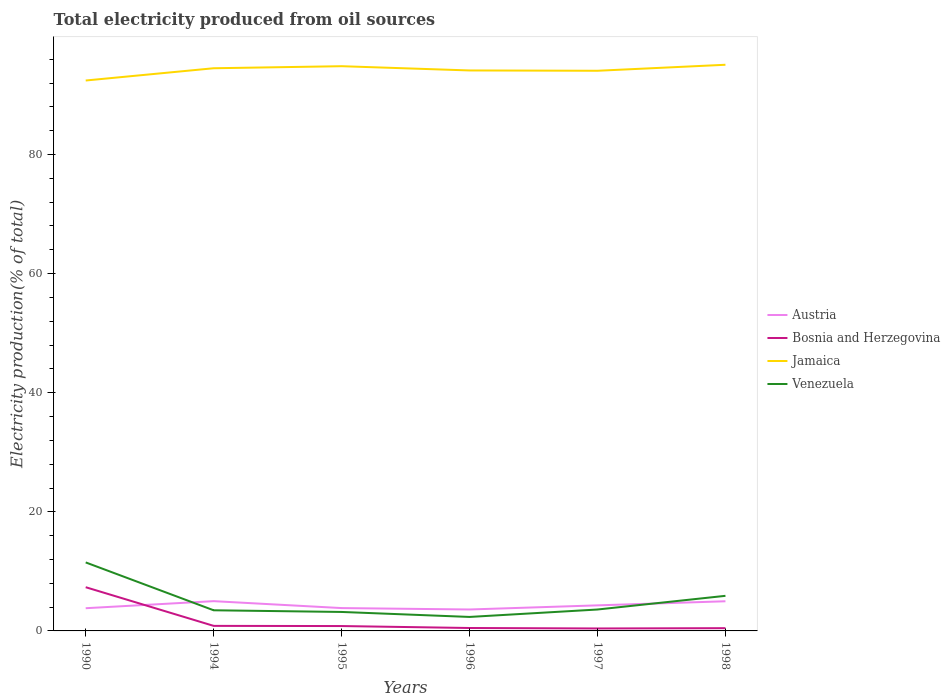How many different coloured lines are there?
Offer a terse response. 4. Does the line corresponding to Bosnia and Herzegovina intersect with the line corresponding to Austria?
Provide a short and direct response. Yes. Is the number of lines equal to the number of legend labels?
Make the answer very short. Yes. Across all years, what is the maximum total electricity produced in Venezuela?
Your answer should be very brief. 2.35. In which year was the total electricity produced in Jamaica maximum?
Provide a succinct answer. 1990. What is the total total electricity produced in Austria in the graph?
Give a very brief answer. -0.69. What is the difference between the highest and the second highest total electricity produced in Austria?
Keep it short and to the point. 1.4. What is the difference between the highest and the lowest total electricity produced in Jamaica?
Offer a terse response. 3. How many years are there in the graph?
Ensure brevity in your answer.  6. Where does the legend appear in the graph?
Your response must be concise. Center right. How many legend labels are there?
Make the answer very short. 4. What is the title of the graph?
Keep it short and to the point. Total electricity produced from oil sources. What is the Electricity production(% of total) in Austria in 1990?
Offer a very short reply. 3.81. What is the Electricity production(% of total) in Bosnia and Herzegovina in 1990?
Your answer should be compact. 7.34. What is the Electricity production(% of total) of Jamaica in 1990?
Provide a succinct answer. 92.43. What is the Electricity production(% of total) in Venezuela in 1990?
Your answer should be compact. 11.5. What is the Electricity production(% of total) in Austria in 1994?
Provide a succinct answer. 5. What is the Electricity production(% of total) of Bosnia and Herzegovina in 1994?
Keep it short and to the point. 0.85. What is the Electricity production(% of total) in Jamaica in 1994?
Give a very brief answer. 94.49. What is the Electricity production(% of total) of Venezuela in 1994?
Your response must be concise. 3.47. What is the Electricity production(% of total) in Austria in 1995?
Make the answer very short. 3.84. What is the Electricity production(% of total) of Bosnia and Herzegovina in 1995?
Provide a short and direct response. 0.82. What is the Electricity production(% of total) in Jamaica in 1995?
Give a very brief answer. 94.84. What is the Electricity production(% of total) of Venezuela in 1995?
Give a very brief answer. 3.18. What is the Electricity production(% of total) in Austria in 1996?
Make the answer very short. 3.6. What is the Electricity production(% of total) in Bosnia and Herzegovina in 1996?
Your answer should be very brief. 0.49. What is the Electricity production(% of total) in Jamaica in 1996?
Offer a terse response. 94.12. What is the Electricity production(% of total) of Venezuela in 1996?
Your answer should be compact. 2.35. What is the Electricity production(% of total) in Austria in 1997?
Give a very brief answer. 4.29. What is the Electricity production(% of total) in Bosnia and Herzegovina in 1997?
Keep it short and to the point. 0.41. What is the Electricity production(% of total) in Jamaica in 1997?
Provide a succinct answer. 94.07. What is the Electricity production(% of total) in Venezuela in 1997?
Keep it short and to the point. 3.6. What is the Electricity production(% of total) of Austria in 1998?
Offer a terse response. 4.98. What is the Electricity production(% of total) in Bosnia and Herzegovina in 1998?
Keep it short and to the point. 0.46. What is the Electricity production(% of total) of Jamaica in 1998?
Your response must be concise. 95.08. What is the Electricity production(% of total) of Venezuela in 1998?
Provide a succinct answer. 5.89. Across all years, what is the maximum Electricity production(% of total) in Austria?
Ensure brevity in your answer.  5. Across all years, what is the maximum Electricity production(% of total) of Bosnia and Herzegovina?
Keep it short and to the point. 7.34. Across all years, what is the maximum Electricity production(% of total) of Jamaica?
Your answer should be very brief. 95.08. Across all years, what is the maximum Electricity production(% of total) of Venezuela?
Your answer should be compact. 11.5. Across all years, what is the minimum Electricity production(% of total) of Austria?
Give a very brief answer. 3.6. Across all years, what is the minimum Electricity production(% of total) in Bosnia and Herzegovina?
Your response must be concise. 0.41. Across all years, what is the minimum Electricity production(% of total) of Jamaica?
Keep it short and to the point. 92.43. Across all years, what is the minimum Electricity production(% of total) in Venezuela?
Give a very brief answer. 2.35. What is the total Electricity production(% of total) of Austria in the graph?
Keep it short and to the point. 25.52. What is the total Electricity production(% of total) of Bosnia and Herzegovina in the graph?
Offer a very short reply. 10.37. What is the total Electricity production(% of total) in Jamaica in the graph?
Your response must be concise. 565.03. What is the total Electricity production(% of total) of Venezuela in the graph?
Provide a short and direct response. 29.99. What is the difference between the Electricity production(% of total) of Austria in 1990 and that in 1994?
Offer a very short reply. -1.19. What is the difference between the Electricity production(% of total) of Bosnia and Herzegovina in 1990 and that in 1994?
Your answer should be compact. 6.49. What is the difference between the Electricity production(% of total) of Jamaica in 1990 and that in 1994?
Keep it short and to the point. -2.06. What is the difference between the Electricity production(% of total) in Venezuela in 1990 and that in 1994?
Provide a short and direct response. 8.04. What is the difference between the Electricity production(% of total) in Austria in 1990 and that in 1995?
Keep it short and to the point. -0.02. What is the difference between the Electricity production(% of total) of Bosnia and Herzegovina in 1990 and that in 1995?
Provide a short and direct response. 6.52. What is the difference between the Electricity production(% of total) in Jamaica in 1990 and that in 1995?
Your answer should be very brief. -2.4. What is the difference between the Electricity production(% of total) in Venezuela in 1990 and that in 1995?
Provide a short and direct response. 8.32. What is the difference between the Electricity production(% of total) in Austria in 1990 and that in 1996?
Give a very brief answer. 0.21. What is the difference between the Electricity production(% of total) in Bosnia and Herzegovina in 1990 and that in 1996?
Give a very brief answer. 6.85. What is the difference between the Electricity production(% of total) of Jamaica in 1990 and that in 1996?
Keep it short and to the point. -1.69. What is the difference between the Electricity production(% of total) in Venezuela in 1990 and that in 1996?
Give a very brief answer. 9.16. What is the difference between the Electricity production(% of total) of Austria in 1990 and that in 1997?
Your response must be concise. -0.48. What is the difference between the Electricity production(% of total) of Bosnia and Herzegovina in 1990 and that in 1997?
Provide a short and direct response. 6.93. What is the difference between the Electricity production(% of total) of Jamaica in 1990 and that in 1997?
Your response must be concise. -1.64. What is the difference between the Electricity production(% of total) in Venezuela in 1990 and that in 1997?
Provide a succinct answer. 7.91. What is the difference between the Electricity production(% of total) in Austria in 1990 and that in 1998?
Your response must be concise. -1.17. What is the difference between the Electricity production(% of total) in Bosnia and Herzegovina in 1990 and that in 1998?
Make the answer very short. 6.88. What is the difference between the Electricity production(% of total) of Jamaica in 1990 and that in 1998?
Give a very brief answer. -2.64. What is the difference between the Electricity production(% of total) in Venezuela in 1990 and that in 1998?
Make the answer very short. 5.61. What is the difference between the Electricity production(% of total) in Austria in 1994 and that in 1995?
Make the answer very short. 1.16. What is the difference between the Electricity production(% of total) of Bosnia and Herzegovina in 1994 and that in 1995?
Give a very brief answer. 0.03. What is the difference between the Electricity production(% of total) in Jamaica in 1994 and that in 1995?
Your answer should be very brief. -0.34. What is the difference between the Electricity production(% of total) in Venezuela in 1994 and that in 1995?
Offer a very short reply. 0.28. What is the difference between the Electricity production(% of total) of Austria in 1994 and that in 1996?
Your answer should be compact. 1.4. What is the difference between the Electricity production(% of total) of Bosnia and Herzegovina in 1994 and that in 1996?
Provide a succinct answer. 0.36. What is the difference between the Electricity production(% of total) in Jamaica in 1994 and that in 1996?
Provide a short and direct response. 0.37. What is the difference between the Electricity production(% of total) in Venezuela in 1994 and that in 1996?
Provide a succinct answer. 1.12. What is the difference between the Electricity production(% of total) in Austria in 1994 and that in 1997?
Provide a succinct answer. 0.71. What is the difference between the Electricity production(% of total) in Bosnia and Herzegovina in 1994 and that in 1997?
Your answer should be very brief. 0.44. What is the difference between the Electricity production(% of total) of Jamaica in 1994 and that in 1997?
Provide a succinct answer. 0.42. What is the difference between the Electricity production(% of total) of Venezuela in 1994 and that in 1997?
Your answer should be very brief. -0.13. What is the difference between the Electricity production(% of total) in Austria in 1994 and that in 1998?
Offer a very short reply. 0.02. What is the difference between the Electricity production(% of total) of Bosnia and Herzegovina in 1994 and that in 1998?
Offer a very short reply. 0.39. What is the difference between the Electricity production(% of total) in Jamaica in 1994 and that in 1998?
Offer a terse response. -0.58. What is the difference between the Electricity production(% of total) of Venezuela in 1994 and that in 1998?
Ensure brevity in your answer.  -2.43. What is the difference between the Electricity production(% of total) of Austria in 1995 and that in 1996?
Ensure brevity in your answer.  0.24. What is the difference between the Electricity production(% of total) in Bosnia and Herzegovina in 1995 and that in 1996?
Offer a terse response. 0.33. What is the difference between the Electricity production(% of total) of Jamaica in 1995 and that in 1996?
Offer a terse response. 0.72. What is the difference between the Electricity production(% of total) in Venezuela in 1995 and that in 1996?
Keep it short and to the point. 0.84. What is the difference between the Electricity production(% of total) in Austria in 1995 and that in 1997?
Offer a terse response. -0.46. What is the difference between the Electricity production(% of total) of Bosnia and Herzegovina in 1995 and that in 1997?
Keep it short and to the point. 0.41. What is the difference between the Electricity production(% of total) of Jamaica in 1995 and that in 1997?
Offer a very short reply. 0.77. What is the difference between the Electricity production(% of total) of Venezuela in 1995 and that in 1997?
Provide a short and direct response. -0.41. What is the difference between the Electricity production(% of total) of Austria in 1995 and that in 1998?
Give a very brief answer. -1.14. What is the difference between the Electricity production(% of total) in Bosnia and Herzegovina in 1995 and that in 1998?
Keep it short and to the point. 0.36. What is the difference between the Electricity production(% of total) of Jamaica in 1995 and that in 1998?
Your answer should be very brief. -0.24. What is the difference between the Electricity production(% of total) of Venezuela in 1995 and that in 1998?
Provide a short and direct response. -2.71. What is the difference between the Electricity production(% of total) of Austria in 1996 and that in 1997?
Give a very brief answer. -0.69. What is the difference between the Electricity production(% of total) of Bosnia and Herzegovina in 1996 and that in 1997?
Offer a very short reply. 0.08. What is the difference between the Electricity production(% of total) of Jamaica in 1996 and that in 1997?
Your answer should be very brief. 0.05. What is the difference between the Electricity production(% of total) in Venezuela in 1996 and that in 1997?
Your response must be concise. -1.25. What is the difference between the Electricity production(% of total) of Austria in 1996 and that in 1998?
Offer a very short reply. -1.38. What is the difference between the Electricity production(% of total) in Bosnia and Herzegovina in 1996 and that in 1998?
Keep it short and to the point. 0.03. What is the difference between the Electricity production(% of total) in Jamaica in 1996 and that in 1998?
Give a very brief answer. -0.96. What is the difference between the Electricity production(% of total) in Venezuela in 1996 and that in 1998?
Your answer should be compact. -3.55. What is the difference between the Electricity production(% of total) in Austria in 1997 and that in 1998?
Ensure brevity in your answer.  -0.69. What is the difference between the Electricity production(% of total) in Bosnia and Herzegovina in 1997 and that in 1998?
Your answer should be compact. -0.05. What is the difference between the Electricity production(% of total) in Jamaica in 1997 and that in 1998?
Make the answer very short. -1.01. What is the difference between the Electricity production(% of total) in Venezuela in 1997 and that in 1998?
Your response must be concise. -2.3. What is the difference between the Electricity production(% of total) of Austria in 1990 and the Electricity production(% of total) of Bosnia and Herzegovina in 1994?
Provide a short and direct response. 2.97. What is the difference between the Electricity production(% of total) of Austria in 1990 and the Electricity production(% of total) of Jamaica in 1994?
Make the answer very short. -90.68. What is the difference between the Electricity production(% of total) of Austria in 1990 and the Electricity production(% of total) of Venezuela in 1994?
Your answer should be very brief. 0.35. What is the difference between the Electricity production(% of total) of Bosnia and Herzegovina in 1990 and the Electricity production(% of total) of Jamaica in 1994?
Offer a very short reply. -87.15. What is the difference between the Electricity production(% of total) of Bosnia and Herzegovina in 1990 and the Electricity production(% of total) of Venezuela in 1994?
Make the answer very short. 3.87. What is the difference between the Electricity production(% of total) in Jamaica in 1990 and the Electricity production(% of total) in Venezuela in 1994?
Provide a succinct answer. 88.97. What is the difference between the Electricity production(% of total) of Austria in 1990 and the Electricity production(% of total) of Bosnia and Herzegovina in 1995?
Your answer should be compact. 3. What is the difference between the Electricity production(% of total) of Austria in 1990 and the Electricity production(% of total) of Jamaica in 1995?
Offer a terse response. -91.02. What is the difference between the Electricity production(% of total) of Austria in 1990 and the Electricity production(% of total) of Venezuela in 1995?
Your answer should be very brief. 0.63. What is the difference between the Electricity production(% of total) in Bosnia and Herzegovina in 1990 and the Electricity production(% of total) in Jamaica in 1995?
Make the answer very short. -87.5. What is the difference between the Electricity production(% of total) in Bosnia and Herzegovina in 1990 and the Electricity production(% of total) in Venezuela in 1995?
Provide a short and direct response. 4.16. What is the difference between the Electricity production(% of total) of Jamaica in 1990 and the Electricity production(% of total) of Venezuela in 1995?
Your answer should be compact. 89.25. What is the difference between the Electricity production(% of total) of Austria in 1990 and the Electricity production(% of total) of Bosnia and Herzegovina in 1996?
Give a very brief answer. 3.32. What is the difference between the Electricity production(% of total) in Austria in 1990 and the Electricity production(% of total) in Jamaica in 1996?
Ensure brevity in your answer.  -90.31. What is the difference between the Electricity production(% of total) in Austria in 1990 and the Electricity production(% of total) in Venezuela in 1996?
Provide a short and direct response. 1.47. What is the difference between the Electricity production(% of total) in Bosnia and Herzegovina in 1990 and the Electricity production(% of total) in Jamaica in 1996?
Ensure brevity in your answer.  -86.78. What is the difference between the Electricity production(% of total) in Bosnia and Herzegovina in 1990 and the Electricity production(% of total) in Venezuela in 1996?
Provide a succinct answer. 4.99. What is the difference between the Electricity production(% of total) of Jamaica in 1990 and the Electricity production(% of total) of Venezuela in 1996?
Give a very brief answer. 90.08. What is the difference between the Electricity production(% of total) in Austria in 1990 and the Electricity production(% of total) in Bosnia and Herzegovina in 1997?
Give a very brief answer. 3.4. What is the difference between the Electricity production(% of total) in Austria in 1990 and the Electricity production(% of total) in Jamaica in 1997?
Give a very brief answer. -90.25. What is the difference between the Electricity production(% of total) of Austria in 1990 and the Electricity production(% of total) of Venezuela in 1997?
Your response must be concise. 0.22. What is the difference between the Electricity production(% of total) of Bosnia and Herzegovina in 1990 and the Electricity production(% of total) of Jamaica in 1997?
Ensure brevity in your answer.  -86.73. What is the difference between the Electricity production(% of total) in Bosnia and Herzegovina in 1990 and the Electricity production(% of total) in Venezuela in 1997?
Provide a succinct answer. 3.74. What is the difference between the Electricity production(% of total) of Jamaica in 1990 and the Electricity production(% of total) of Venezuela in 1997?
Give a very brief answer. 88.84. What is the difference between the Electricity production(% of total) in Austria in 1990 and the Electricity production(% of total) in Bosnia and Herzegovina in 1998?
Provide a succinct answer. 3.35. What is the difference between the Electricity production(% of total) of Austria in 1990 and the Electricity production(% of total) of Jamaica in 1998?
Your response must be concise. -91.26. What is the difference between the Electricity production(% of total) in Austria in 1990 and the Electricity production(% of total) in Venezuela in 1998?
Your response must be concise. -2.08. What is the difference between the Electricity production(% of total) of Bosnia and Herzegovina in 1990 and the Electricity production(% of total) of Jamaica in 1998?
Offer a very short reply. -87.74. What is the difference between the Electricity production(% of total) in Bosnia and Herzegovina in 1990 and the Electricity production(% of total) in Venezuela in 1998?
Offer a terse response. 1.45. What is the difference between the Electricity production(% of total) in Jamaica in 1990 and the Electricity production(% of total) in Venezuela in 1998?
Give a very brief answer. 86.54. What is the difference between the Electricity production(% of total) in Austria in 1994 and the Electricity production(% of total) in Bosnia and Herzegovina in 1995?
Keep it short and to the point. 4.18. What is the difference between the Electricity production(% of total) of Austria in 1994 and the Electricity production(% of total) of Jamaica in 1995?
Your answer should be very brief. -89.84. What is the difference between the Electricity production(% of total) of Austria in 1994 and the Electricity production(% of total) of Venezuela in 1995?
Make the answer very short. 1.81. What is the difference between the Electricity production(% of total) of Bosnia and Herzegovina in 1994 and the Electricity production(% of total) of Jamaica in 1995?
Your response must be concise. -93.99. What is the difference between the Electricity production(% of total) of Bosnia and Herzegovina in 1994 and the Electricity production(% of total) of Venezuela in 1995?
Make the answer very short. -2.34. What is the difference between the Electricity production(% of total) in Jamaica in 1994 and the Electricity production(% of total) in Venezuela in 1995?
Provide a short and direct response. 91.31. What is the difference between the Electricity production(% of total) in Austria in 1994 and the Electricity production(% of total) in Bosnia and Herzegovina in 1996?
Your answer should be very brief. 4.51. What is the difference between the Electricity production(% of total) of Austria in 1994 and the Electricity production(% of total) of Jamaica in 1996?
Offer a terse response. -89.12. What is the difference between the Electricity production(% of total) in Austria in 1994 and the Electricity production(% of total) in Venezuela in 1996?
Your answer should be compact. 2.65. What is the difference between the Electricity production(% of total) of Bosnia and Herzegovina in 1994 and the Electricity production(% of total) of Jamaica in 1996?
Your response must be concise. -93.27. What is the difference between the Electricity production(% of total) in Bosnia and Herzegovina in 1994 and the Electricity production(% of total) in Venezuela in 1996?
Keep it short and to the point. -1.5. What is the difference between the Electricity production(% of total) of Jamaica in 1994 and the Electricity production(% of total) of Venezuela in 1996?
Your answer should be very brief. 92.14. What is the difference between the Electricity production(% of total) of Austria in 1994 and the Electricity production(% of total) of Bosnia and Herzegovina in 1997?
Provide a short and direct response. 4.59. What is the difference between the Electricity production(% of total) of Austria in 1994 and the Electricity production(% of total) of Jamaica in 1997?
Your answer should be compact. -89.07. What is the difference between the Electricity production(% of total) of Austria in 1994 and the Electricity production(% of total) of Venezuela in 1997?
Offer a terse response. 1.4. What is the difference between the Electricity production(% of total) of Bosnia and Herzegovina in 1994 and the Electricity production(% of total) of Jamaica in 1997?
Your response must be concise. -93.22. What is the difference between the Electricity production(% of total) in Bosnia and Herzegovina in 1994 and the Electricity production(% of total) in Venezuela in 1997?
Make the answer very short. -2.75. What is the difference between the Electricity production(% of total) of Jamaica in 1994 and the Electricity production(% of total) of Venezuela in 1997?
Make the answer very short. 90.9. What is the difference between the Electricity production(% of total) in Austria in 1994 and the Electricity production(% of total) in Bosnia and Herzegovina in 1998?
Your answer should be compact. 4.54. What is the difference between the Electricity production(% of total) in Austria in 1994 and the Electricity production(% of total) in Jamaica in 1998?
Ensure brevity in your answer.  -90.08. What is the difference between the Electricity production(% of total) in Austria in 1994 and the Electricity production(% of total) in Venezuela in 1998?
Keep it short and to the point. -0.89. What is the difference between the Electricity production(% of total) of Bosnia and Herzegovina in 1994 and the Electricity production(% of total) of Jamaica in 1998?
Offer a very short reply. -94.23. What is the difference between the Electricity production(% of total) of Bosnia and Herzegovina in 1994 and the Electricity production(% of total) of Venezuela in 1998?
Ensure brevity in your answer.  -5.05. What is the difference between the Electricity production(% of total) of Jamaica in 1994 and the Electricity production(% of total) of Venezuela in 1998?
Make the answer very short. 88.6. What is the difference between the Electricity production(% of total) in Austria in 1995 and the Electricity production(% of total) in Bosnia and Herzegovina in 1996?
Make the answer very short. 3.35. What is the difference between the Electricity production(% of total) of Austria in 1995 and the Electricity production(% of total) of Jamaica in 1996?
Give a very brief answer. -90.28. What is the difference between the Electricity production(% of total) in Austria in 1995 and the Electricity production(% of total) in Venezuela in 1996?
Your response must be concise. 1.49. What is the difference between the Electricity production(% of total) in Bosnia and Herzegovina in 1995 and the Electricity production(% of total) in Jamaica in 1996?
Offer a terse response. -93.3. What is the difference between the Electricity production(% of total) of Bosnia and Herzegovina in 1995 and the Electricity production(% of total) of Venezuela in 1996?
Your response must be concise. -1.53. What is the difference between the Electricity production(% of total) of Jamaica in 1995 and the Electricity production(% of total) of Venezuela in 1996?
Keep it short and to the point. 92.49. What is the difference between the Electricity production(% of total) in Austria in 1995 and the Electricity production(% of total) in Bosnia and Herzegovina in 1997?
Offer a terse response. 3.43. What is the difference between the Electricity production(% of total) in Austria in 1995 and the Electricity production(% of total) in Jamaica in 1997?
Offer a very short reply. -90.23. What is the difference between the Electricity production(% of total) of Austria in 1995 and the Electricity production(% of total) of Venezuela in 1997?
Keep it short and to the point. 0.24. What is the difference between the Electricity production(% of total) of Bosnia and Herzegovina in 1995 and the Electricity production(% of total) of Jamaica in 1997?
Your response must be concise. -93.25. What is the difference between the Electricity production(% of total) of Bosnia and Herzegovina in 1995 and the Electricity production(% of total) of Venezuela in 1997?
Make the answer very short. -2.78. What is the difference between the Electricity production(% of total) of Jamaica in 1995 and the Electricity production(% of total) of Venezuela in 1997?
Offer a terse response. 91.24. What is the difference between the Electricity production(% of total) in Austria in 1995 and the Electricity production(% of total) in Bosnia and Herzegovina in 1998?
Provide a succinct answer. 3.37. What is the difference between the Electricity production(% of total) of Austria in 1995 and the Electricity production(% of total) of Jamaica in 1998?
Offer a terse response. -91.24. What is the difference between the Electricity production(% of total) in Austria in 1995 and the Electricity production(% of total) in Venezuela in 1998?
Your answer should be very brief. -2.06. What is the difference between the Electricity production(% of total) of Bosnia and Herzegovina in 1995 and the Electricity production(% of total) of Jamaica in 1998?
Give a very brief answer. -94.26. What is the difference between the Electricity production(% of total) in Bosnia and Herzegovina in 1995 and the Electricity production(% of total) in Venezuela in 1998?
Keep it short and to the point. -5.08. What is the difference between the Electricity production(% of total) of Jamaica in 1995 and the Electricity production(% of total) of Venezuela in 1998?
Provide a succinct answer. 88.94. What is the difference between the Electricity production(% of total) of Austria in 1996 and the Electricity production(% of total) of Bosnia and Herzegovina in 1997?
Your response must be concise. 3.19. What is the difference between the Electricity production(% of total) of Austria in 1996 and the Electricity production(% of total) of Jamaica in 1997?
Give a very brief answer. -90.47. What is the difference between the Electricity production(% of total) in Austria in 1996 and the Electricity production(% of total) in Venezuela in 1997?
Ensure brevity in your answer.  0. What is the difference between the Electricity production(% of total) in Bosnia and Herzegovina in 1996 and the Electricity production(% of total) in Jamaica in 1997?
Give a very brief answer. -93.58. What is the difference between the Electricity production(% of total) in Bosnia and Herzegovina in 1996 and the Electricity production(% of total) in Venezuela in 1997?
Your answer should be compact. -3.11. What is the difference between the Electricity production(% of total) of Jamaica in 1996 and the Electricity production(% of total) of Venezuela in 1997?
Keep it short and to the point. 90.52. What is the difference between the Electricity production(% of total) of Austria in 1996 and the Electricity production(% of total) of Bosnia and Herzegovina in 1998?
Offer a terse response. 3.14. What is the difference between the Electricity production(% of total) of Austria in 1996 and the Electricity production(% of total) of Jamaica in 1998?
Provide a succinct answer. -91.48. What is the difference between the Electricity production(% of total) in Austria in 1996 and the Electricity production(% of total) in Venezuela in 1998?
Your response must be concise. -2.29. What is the difference between the Electricity production(% of total) of Bosnia and Herzegovina in 1996 and the Electricity production(% of total) of Jamaica in 1998?
Give a very brief answer. -94.59. What is the difference between the Electricity production(% of total) of Bosnia and Herzegovina in 1996 and the Electricity production(% of total) of Venezuela in 1998?
Keep it short and to the point. -5.4. What is the difference between the Electricity production(% of total) in Jamaica in 1996 and the Electricity production(% of total) in Venezuela in 1998?
Ensure brevity in your answer.  88.23. What is the difference between the Electricity production(% of total) in Austria in 1997 and the Electricity production(% of total) in Bosnia and Herzegovina in 1998?
Make the answer very short. 3.83. What is the difference between the Electricity production(% of total) in Austria in 1997 and the Electricity production(% of total) in Jamaica in 1998?
Give a very brief answer. -90.78. What is the difference between the Electricity production(% of total) in Austria in 1997 and the Electricity production(% of total) in Venezuela in 1998?
Ensure brevity in your answer.  -1.6. What is the difference between the Electricity production(% of total) of Bosnia and Herzegovina in 1997 and the Electricity production(% of total) of Jamaica in 1998?
Your answer should be very brief. -94.67. What is the difference between the Electricity production(% of total) of Bosnia and Herzegovina in 1997 and the Electricity production(% of total) of Venezuela in 1998?
Your answer should be compact. -5.48. What is the difference between the Electricity production(% of total) of Jamaica in 1997 and the Electricity production(% of total) of Venezuela in 1998?
Make the answer very short. 88.18. What is the average Electricity production(% of total) of Austria per year?
Provide a succinct answer. 4.25. What is the average Electricity production(% of total) in Bosnia and Herzegovina per year?
Your answer should be very brief. 1.73. What is the average Electricity production(% of total) in Jamaica per year?
Make the answer very short. 94.17. What is the average Electricity production(% of total) in Venezuela per year?
Provide a succinct answer. 5. In the year 1990, what is the difference between the Electricity production(% of total) of Austria and Electricity production(% of total) of Bosnia and Herzegovina?
Give a very brief answer. -3.53. In the year 1990, what is the difference between the Electricity production(% of total) in Austria and Electricity production(% of total) in Jamaica?
Offer a very short reply. -88.62. In the year 1990, what is the difference between the Electricity production(% of total) in Austria and Electricity production(% of total) in Venezuela?
Offer a very short reply. -7.69. In the year 1990, what is the difference between the Electricity production(% of total) of Bosnia and Herzegovina and Electricity production(% of total) of Jamaica?
Your answer should be very brief. -85.09. In the year 1990, what is the difference between the Electricity production(% of total) in Bosnia and Herzegovina and Electricity production(% of total) in Venezuela?
Your answer should be compact. -4.16. In the year 1990, what is the difference between the Electricity production(% of total) in Jamaica and Electricity production(% of total) in Venezuela?
Provide a succinct answer. 80.93. In the year 1994, what is the difference between the Electricity production(% of total) in Austria and Electricity production(% of total) in Bosnia and Herzegovina?
Your response must be concise. 4.15. In the year 1994, what is the difference between the Electricity production(% of total) of Austria and Electricity production(% of total) of Jamaica?
Your response must be concise. -89.49. In the year 1994, what is the difference between the Electricity production(% of total) of Austria and Electricity production(% of total) of Venezuela?
Make the answer very short. 1.53. In the year 1994, what is the difference between the Electricity production(% of total) in Bosnia and Herzegovina and Electricity production(% of total) in Jamaica?
Give a very brief answer. -93.64. In the year 1994, what is the difference between the Electricity production(% of total) in Bosnia and Herzegovina and Electricity production(% of total) in Venezuela?
Offer a terse response. -2.62. In the year 1994, what is the difference between the Electricity production(% of total) of Jamaica and Electricity production(% of total) of Venezuela?
Your answer should be compact. 91.03. In the year 1995, what is the difference between the Electricity production(% of total) of Austria and Electricity production(% of total) of Bosnia and Herzegovina?
Give a very brief answer. 3.02. In the year 1995, what is the difference between the Electricity production(% of total) of Austria and Electricity production(% of total) of Jamaica?
Keep it short and to the point. -91. In the year 1995, what is the difference between the Electricity production(% of total) of Austria and Electricity production(% of total) of Venezuela?
Your response must be concise. 0.65. In the year 1995, what is the difference between the Electricity production(% of total) of Bosnia and Herzegovina and Electricity production(% of total) of Jamaica?
Offer a terse response. -94.02. In the year 1995, what is the difference between the Electricity production(% of total) of Bosnia and Herzegovina and Electricity production(% of total) of Venezuela?
Ensure brevity in your answer.  -2.37. In the year 1995, what is the difference between the Electricity production(% of total) in Jamaica and Electricity production(% of total) in Venezuela?
Your answer should be compact. 91.65. In the year 1996, what is the difference between the Electricity production(% of total) of Austria and Electricity production(% of total) of Bosnia and Herzegovina?
Provide a short and direct response. 3.11. In the year 1996, what is the difference between the Electricity production(% of total) of Austria and Electricity production(% of total) of Jamaica?
Your answer should be compact. -90.52. In the year 1996, what is the difference between the Electricity production(% of total) in Austria and Electricity production(% of total) in Venezuela?
Your answer should be compact. 1.25. In the year 1996, what is the difference between the Electricity production(% of total) in Bosnia and Herzegovina and Electricity production(% of total) in Jamaica?
Provide a short and direct response. -93.63. In the year 1996, what is the difference between the Electricity production(% of total) in Bosnia and Herzegovina and Electricity production(% of total) in Venezuela?
Give a very brief answer. -1.86. In the year 1996, what is the difference between the Electricity production(% of total) in Jamaica and Electricity production(% of total) in Venezuela?
Make the answer very short. 91.77. In the year 1997, what is the difference between the Electricity production(% of total) of Austria and Electricity production(% of total) of Bosnia and Herzegovina?
Offer a terse response. 3.88. In the year 1997, what is the difference between the Electricity production(% of total) of Austria and Electricity production(% of total) of Jamaica?
Keep it short and to the point. -89.77. In the year 1997, what is the difference between the Electricity production(% of total) of Austria and Electricity production(% of total) of Venezuela?
Provide a short and direct response. 0.7. In the year 1997, what is the difference between the Electricity production(% of total) in Bosnia and Herzegovina and Electricity production(% of total) in Jamaica?
Your response must be concise. -93.66. In the year 1997, what is the difference between the Electricity production(% of total) of Bosnia and Herzegovina and Electricity production(% of total) of Venezuela?
Give a very brief answer. -3.19. In the year 1997, what is the difference between the Electricity production(% of total) in Jamaica and Electricity production(% of total) in Venezuela?
Make the answer very short. 90.47. In the year 1998, what is the difference between the Electricity production(% of total) in Austria and Electricity production(% of total) in Bosnia and Herzegovina?
Provide a short and direct response. 4.52. In the year 1998, what is the difference between the Electricity production(% of total) in Austria and Electricity production(% of total) in Jamaica?
Provide a short and direct response. -90.1. In the year 1998, what is the difference between the Electricity production(% of total) of Austria and Electricity production(% of total) of Venezuela?
Offer a terse response. -0.91. In the year 1998, what is the difference between the Electricity production(% of total) in Bosnia and Herzegovina and Electricity production(% of total) in Jamaica?
Your answer should be very brief. -94.61. In the year 1998, what is the difference between the Electricity production(% of total) in Bosnia and Herzegovina and Electricity production(% of total) in Venezuela?
Your response must be concise. -5.43. In the year 1998, what is the difference between the Electricity production(% of total) of Jamaica and Electricity production(% of total) of Venezuela?
Make the answer very short. 89.18. What is the ratio of the Electricity production(% of total) in Austria in 1990 to that in 1994?
Provide a short and direct response. 0.76. What is the ratio of the Electricity production(% of total) in Bosnia and Herzegovina in 1990 to that in 1994?
Your answer should be very brief. 8.65. What is the ratio of the Electricity production(% of total) of Jamaica in 1990 to that in 1994?
Keep it short and to the point. 0.98. What is the ratio of the Electricity production(% of total) in Venezuela in 1990 to that in 1994?
Keep it short and to the point. 3.32. What is the ratio of the Electricity production(% of total) in Austria in 1990 to that in 1995?
Your answer should be very brief. 0.99. What is the ratio of the Electricity production(% of total) of Bosnia and Herzegovina in 1990 to that in 1995?
Keep it short and to the point. 8.97. What is the ratio of the Electricity production(% of total) of Jamaica in 1990 to that in 1995?
Your answer should be compact. 0.97. What is the ratio of the Electricity production(% of total) of Venezuela in 1990 to that in 1995?
Ensure brevity in your answer.  3.61. What is the ratio of the Electricity production(% of total) of Austria in 1990 to that in 1996?
Offer a terse response. 1.06. What is the ratio of the Electricity production(% of total) in Bosnia and Herzegovina in 1990 to that in 1996?
Your response must be concise. 14.97. What is the ratio of the Electricity production(% of total) in Jamaica in 1990 to that in 1996?
Make the answer very short. 0.98. What is the ratio of the Electricity production(% of total) of Venezuela in 1990 to that in 1996?
Give a very brief answer. 4.9. What is the ratio of the Electricity production(% of total) in Austria in 1990 to that in 1997?
Provide a succinct answer. 0.89. What is the ratio of the Electricity production(% of total) in Bosnia and Herzegovina in 1990 to that in 1997?
Provide a succinct answer. 17.87. What is the ratio of the Electricity production(% of total) of Jamaica in 1990 to that in 1997?
Ensure brevity in your answer.  0.98. What is the ratio of the Electricity production(% of total) of Venezuela in 1990 to that in 1997?
Your response must be concise. 3.2. What is the ratio of the Electricity production(% of total) of Austria in 1990 to that in 1998?
Offer a very short reply. 0.77. What is the ratio of the Electricity production(% of total) of Bosnia and Herzegovina in 1990 to that in 1998?
Ensure brevity in your answer.  15.86. What is the ratio of the Electricity production(% of total) of Jamaica in 1990 to that in 1998?
Your response must be concise. 0.97. What is the ratio of the Electricity production(% of total) of Venezuela in 1990 to that in 1998?
Ensure brevity in your answer.  1.95. What is the ratio of the Electricity production(% of total) in Austria in 1994 to that in 1995?
Offer a terse response. 1.3. What is the ratio of the Electricity production(% of total) in Bosnia and Herzegovina in 1994 to that in 1995?
Give a very brief answer. 1.04. What is the ratio of the Electricity production(% of total) of Venezuela in 1994 to that in 1995?
Your response must be concise. 1.09. What is the ratio of the Electricity production(% of total) of Austria in 1994 to that in 1996?
Your answer should be compact. 1.39. What is the ratio of the Electricity production(% of total) in Bosnia and Herzegovina in 1994 to that in 1996?
Your response must be concise. 1.73. What is the ratio of the Electricity production(% of total) in Venezuela in 1994 to that in 1996?
Your response must be concise. 1.48. What is the ratio of the Electricity production(% of total) in Austria in 1994 to that in 1997?
Provide a succinct answer. 1.16. What is the ratio of the Electricity production(% of total) in Bosnia and Herzegovina in 1994 to that in 1997?
Offer a very short reply. 2.07. What is the ratio of the Electricity production(% of total) in Venezuela in 1994 to that in 1997?
Offer a terse response. 0.96. What is the ratio of the Electricity production(% of total) of Austria in 1994 to that in 1998?
Your response must be concise. 1. What is the ratio of the Electricity production(% of total) in Bosnia and Herzegovina in 1994 to that in 1998?
Give a very brief answer. 1.83. What is the ratio of the Electricity production(% of total) in Jamaica in 1994 to that in 1998?
Provide a succinct answer. 0.99. What is the ratio of the Electricity production(% of total) of Venezuela in 1994 to that in 1998?
Make the answer very short. 0.59. What is the ratio of the Electricity production(% of total) in Austria in 1995 to that in 1996?
Keep it short and to the point. 1.07. What is the ratio of the Electricity production(% of total) of Bosnia and Herzegovina in 1995 to that in 1996?
Your response must be concise. 1.67. What is the ratio of the Electricity production(% of total) of Jamaica in 1995 to that in 1996?
Your answer should be very brief. 1.01. What is the ratio of the Electricity production(% of total) in Venezuela in 1995 to that in 1996?
Ensure brevity in your answer.  1.36. What is the ratio of the Electricity production(% of total) in Austria in 1995 to that in 1997?
Offer a very short reply. 0.89. What is the ratio of the Electricity production(% of total) in Bosnia and Herzegovina in 1995 to that in 1997?
Ensure brevity in your answer.  1.99. What is the ratio of the Electricity production(% of total) in Jamaica in 1995 to that in 1997?
Keep it short and to the point. 1.01. What is the ratio of the Electricity production(% of total) of Venezuela in 1995 to that in 1997?
Provide a short and direct response. 0.89. What is the ratio of the Electricity production(% of total) in Austria in 1995 to that in 1998?
Make the answer very short. 0.77. What is the ratio of the Electricity production(% of total) in Bosnia and Herzegovina in 1995 to that in 1998?
Provide a short and direct response. 1.77. What is the ratio of the Electricity production(% of total) in Jamaica in 1995 to that in 1998?
Make the answer very short. 1. What is the ratio of the Electricity production(% of total) of Venezuela in 1995 to that in 1998?
Provide a succinct answer. 0.54. What is the ratio of the Electricity production(% of total) of Austria in 1996 to that in 1997?
Offer a very short reply. 0.84. What is the ratio of the Electricity production(% of total) in Bosnia and Herzegovina in 1996 to that in 1997?
Provide a succinct answer. 1.19. What is the ratio of the Electricity production(% of total) in Jamaica in 1996 to that in 1997?
Make the answer very short. 1. What is the ratio of the Electricity production(% of total) in Venezuela in 1996 to that in 1997?
Ensure brevity in your answer.  0.65. What is the ratio of the Electricity production(% of total) in Austria in 1996 to that in 1998?
Your response must be concise. 0.72. What is the ratio of the Electricity production(% of total) of Bosnia and Herzegovina in 1996 to that in 1998?
Offer a very short reply. 1.06. What is the ratio of the Electricity production(% of total) in Venezuela in 1996 to that in 1998?
Ensure brevity in your answer.  0.4. What is the ratio of the Electricity production(% of total) in Austria in 1997 to that in 1998?
Ensure brevity in your answer.  0.86. What is the ratio of the Electricity production(% of total) of Bosnia and Herzegovina in 1997 to that in 1998?
Provide a short and direct response. 0.89. What is the ratio of the Electricity production(% of total) of Jamaica in 1997 to that in 1998?
Offer a terse response. 0.99. What is the ratio of the Electricity production(% of total) of Venezuela in 1997 to that in 1998?
Make the answer very short. 0.61. What is the difference between the highest and the second highest Electricity production(% of total) of Austria?
Offer a very short reply. 0.02. What is the difference between the highest and the second highest Electricity production(% of total) in Bosnia and Herzegovina?
Provide a short and direct response. 6.49. What is the difference between the highest and the second highest Electricity production(% of total) of Jamaica?
Provide a succinct answer. 0.24. What is the difference between the highest and the second highest Electricity production(% of total) in Venezuela?
Ensure brevity in your answer.  5.61. What is the difference between the highest and the lowest Electricity production(% of total) of Austria?
Provide a short and direct response. 1.4. What is the difference between the highest and the lowest Electricity production(% of total) in Bosnia and Herzegovina?
Your answer should be very brief. 6.93. What is the difference between the highest and the lowest Electricity production(% of total) of Jamaica?
Keep it short and to the point. 2.64. What is the difference between the highest and the lowest Electricity production(% of total) in Venezuela?
Your response must be concise. 9.16. 